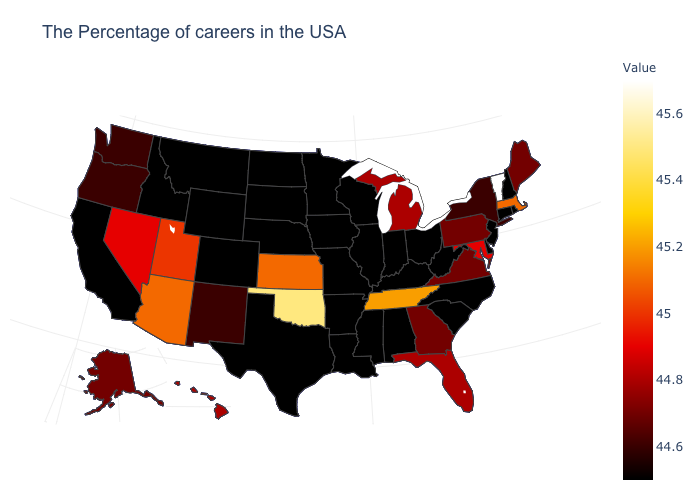Is the legend a continuous bar?
Concise answer only. Yes. Does Hawaii have the lowest value in the West?
Answer briefly. No. Among the states that border Kansas , does Colorado have the lowest value?
Keep it brief. Yes. Does the map have missing data?
Give a very brief answer. No. 